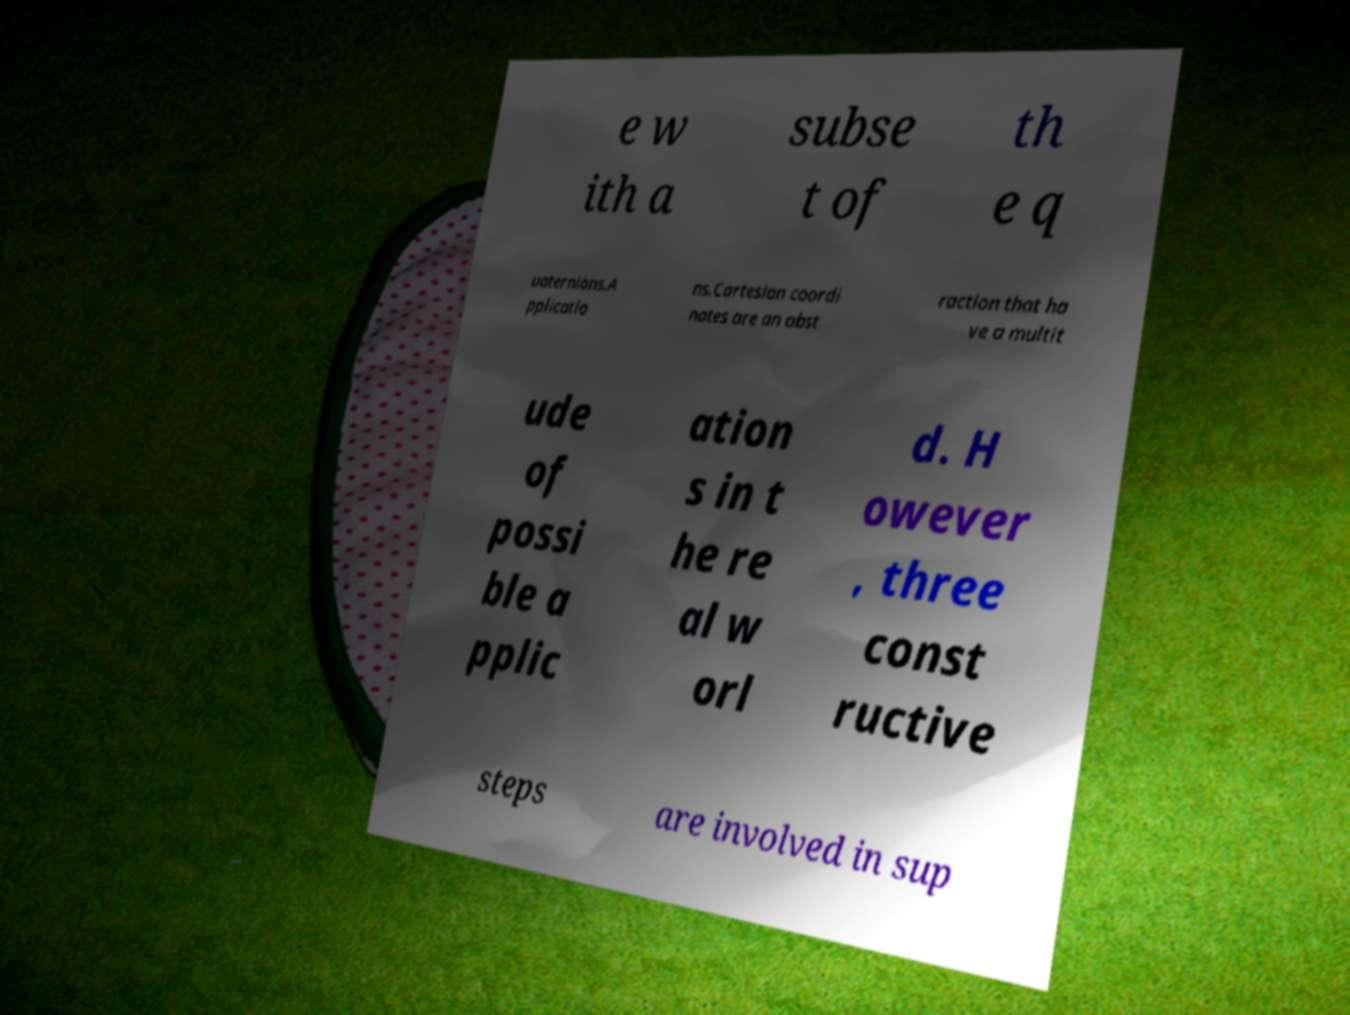What messages or text are displayed in this image? I need them in a readable, typed format. e w ith a subse t of th e q uaternions.A pplicatio ns.Cartesian coordi nates are an abst raction that ha ve a multit ude of possi ble a pplic ation s in t he re al w orl d. H owever , three const ructive steps are involved in sup 